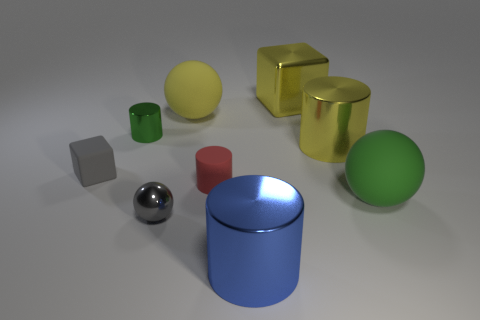Subtract all cylinders. How many objects are left? 5 Subtract all yellow blocks. How many blocks are left? 1 Subtract all rubber spheres. How many spheres are left? 1 Subtract 1 yellow blocks. How many objects are left? 8 Subtract 1 cubes. How many cubes are left? 1 Subtract all green cubes. Subtract all green cylinders. How many cubes are left? 2 Subtract all yellow cubes. How many green spheres are left? 1 Subtract all tiny gray matte blocks. Subtract all cylinders. How many objects are left? 4 Add 5 large shiny cylinders. How many large shiny cylinders are left? 7 Add 7 yellow objects. How many yellow objects exist? 10 